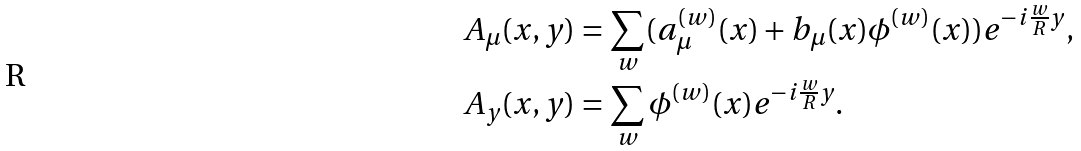<formula> <loc_0><loc_0><loc_500><loc_500>A _ { \mu } ( x , y ) & = \sum _ { w } ( a _ { \mu } ^ { ( w ) } ( x ) + b _ { \mu } ( x ) \phi ^ { ( w ) } ( x ) ) e ^ { - i \frac { w } { R } y } , \\ A _ { y } ( x , y ) & = \sum _ { w } \phi ^ { ( w ) } ( x ) e ^ { - i \frac { w } { R } y } .</formula> 